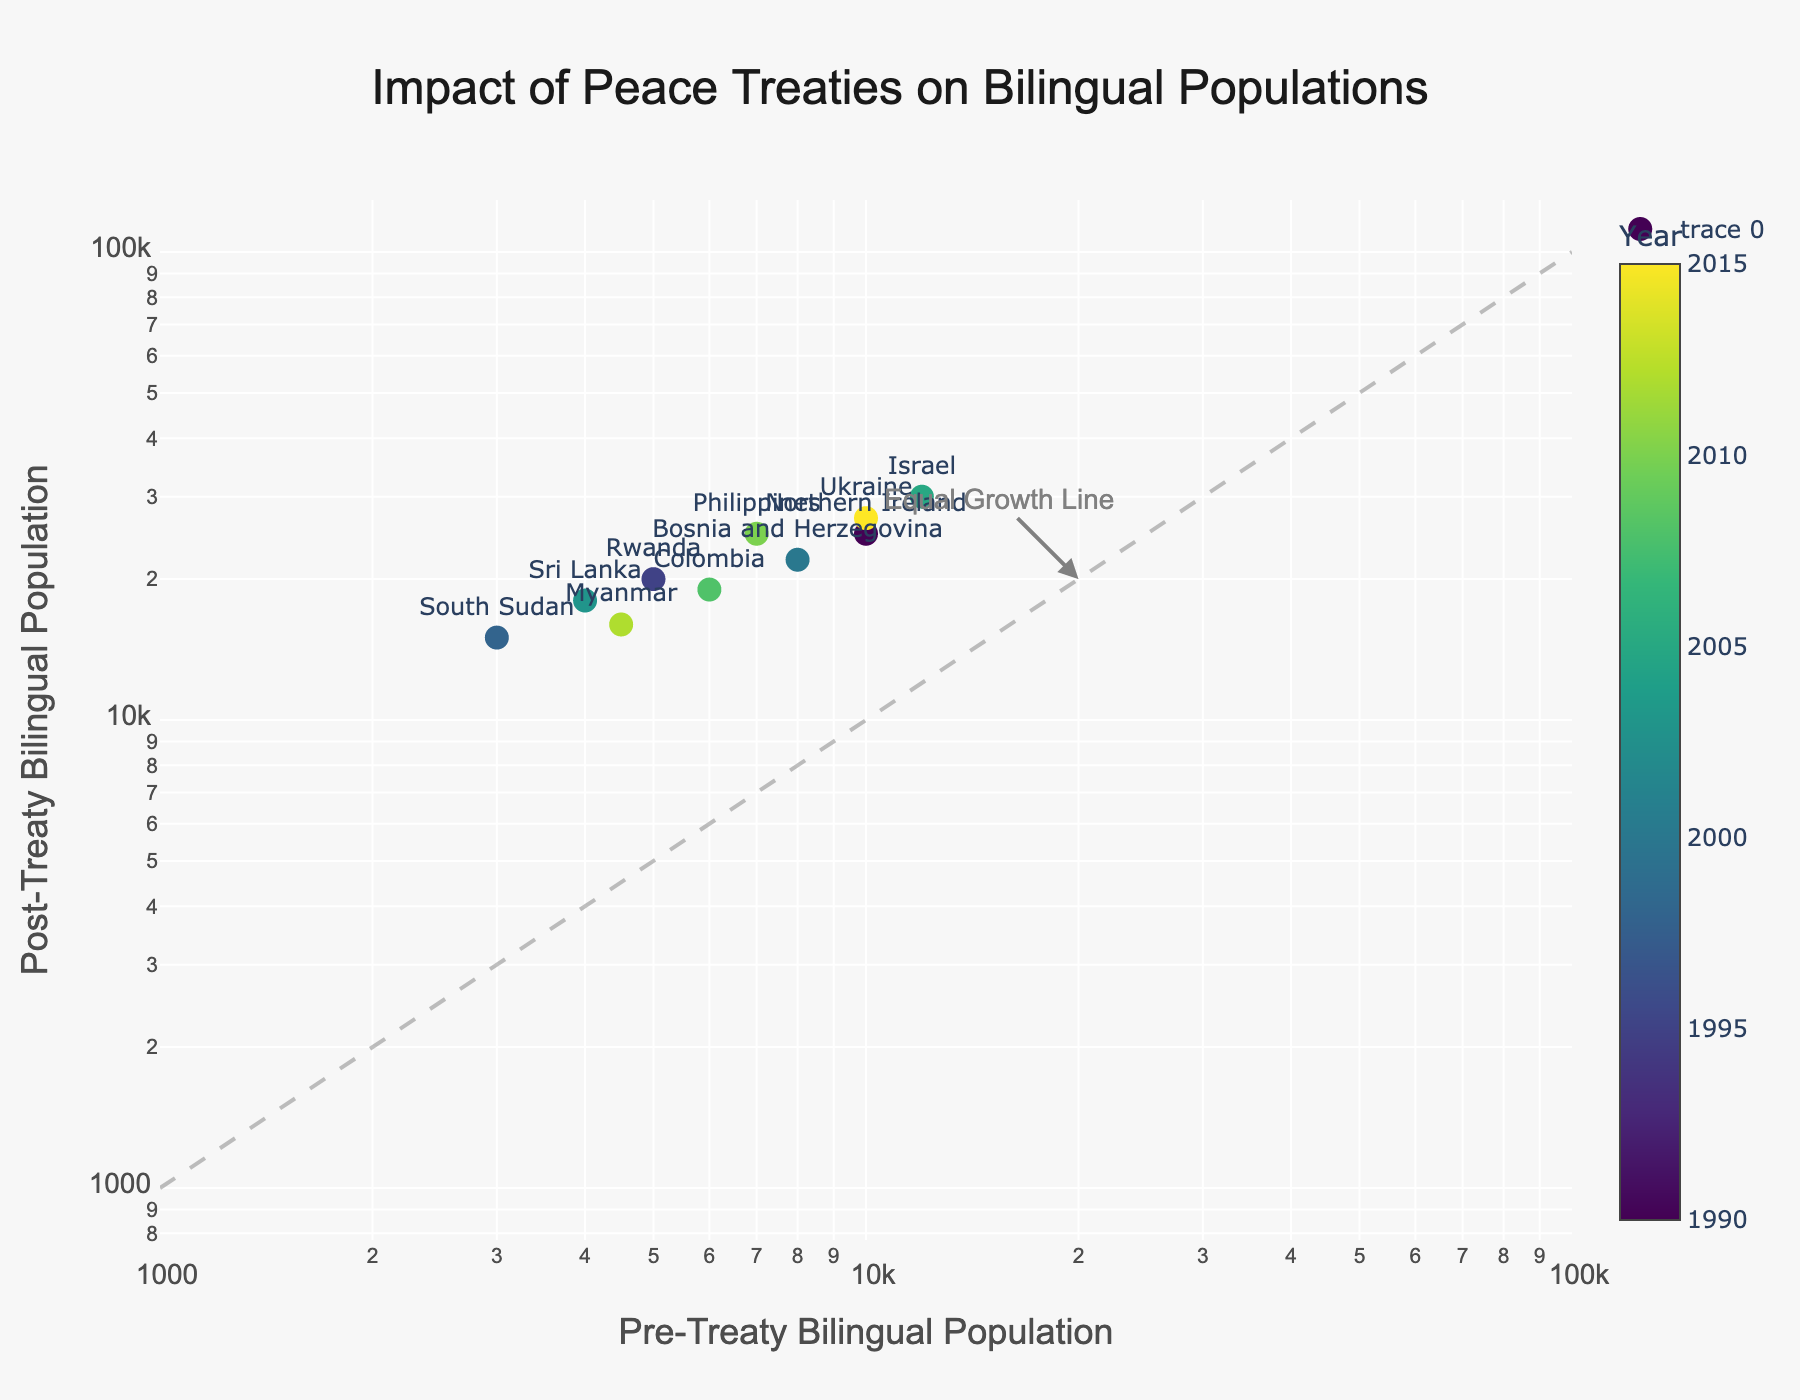How many countries are represented in the plot? Count the unique number of different countries labeled on the plot
Answer: 10 What is the title of the figure? Look for the text at the top center of the plot with larger font size compared to other text in the figure
Answer: Impact of Peace Treaties on Bilingual Populations Which country saw the highest post-treaty bilingual population? Identify the point with the highest y-axis (post-treaty population) value
Answer: Israel Which country has the smallest pre-treaty bilingual population? Identify the point with the lowest x-axis (pre-treaty population) value
Answer: South Sudan What's the difference in post-treaty bilingual population between Northern Ireland and Ukraine? Find the y-axis values for both Northern Ireland and Ukraine, then subtract Northern Ireland's value from Ukraine's value (27000 - 25000)
Answer: 2000 Is there any country where the pre-treaty bilingual population is equal to the post-treaty bilingual population? Check if any data points lie on the diagonal line added as the 'Equal Growth Line'
Answer: No Which regions show a post-treaty bilingual population greater than 20,000? Identify the points with y-axis values greater than 20,000 and list their corresponding regions
Answer: Belfast, Sarajevo, Jerusalem, Kyiv, Manila What is the average pre-treaty bilingual population of all the countries represented? Sum all pre-treaty population values and divide by the number of countries (10000 + 5000 + 3000 + 8000 + 4000 + 12000 + 6000 + 7000 + 4500 + 10000) / 10 = 61,500 / 10
Answer: 6150 Which country realized the highest multiplier effect in bilingual population due to the peace treaty? Calculate the ratio of post-treaty to pre-treaty population for each country and identify the largest ratio. (e.g., Rwanda: 20000/5000 = 4, South Sudan: 15000/3000 = 5, etc.)
Answer: South Sudan (5x) Do all countries exhibit an increase in bilingual population post-treaty? Check if all data points lie above the 'Equal Growth Line' that denotes equal pre- and post-treaty populations
Answer: Yes 